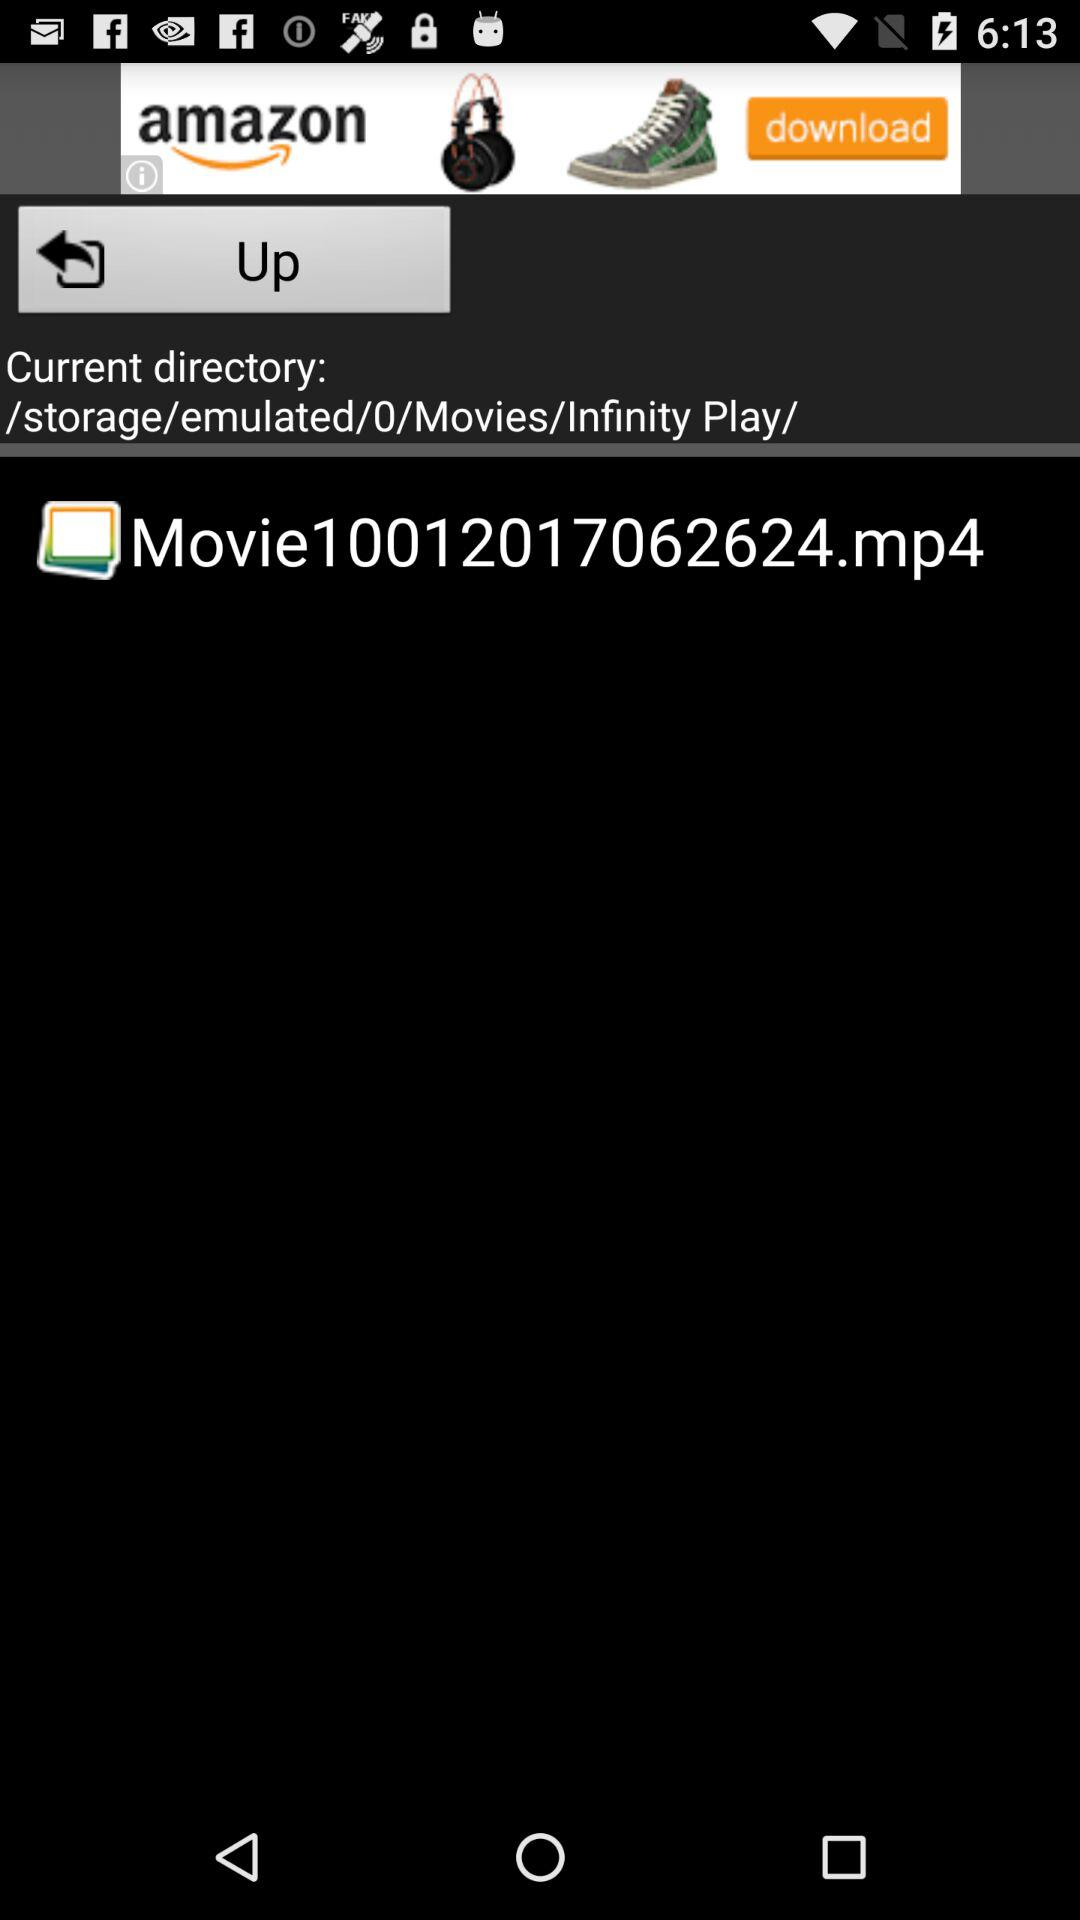What is the storage location of the video "Movie10012017062624.mp4"? The storage location is /storage/emulated/0/Movies/Infinity Play/. 